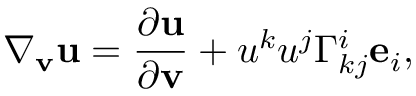<formula> <loc_0><loc_0><loc_500><loc_500>\nabla _ { v } u = \frac { \partial u } { \partial v } + u ^ { k } u ^ { j } \Gamma _ { k j } ^ { i } e _ { i } ,</formula> 